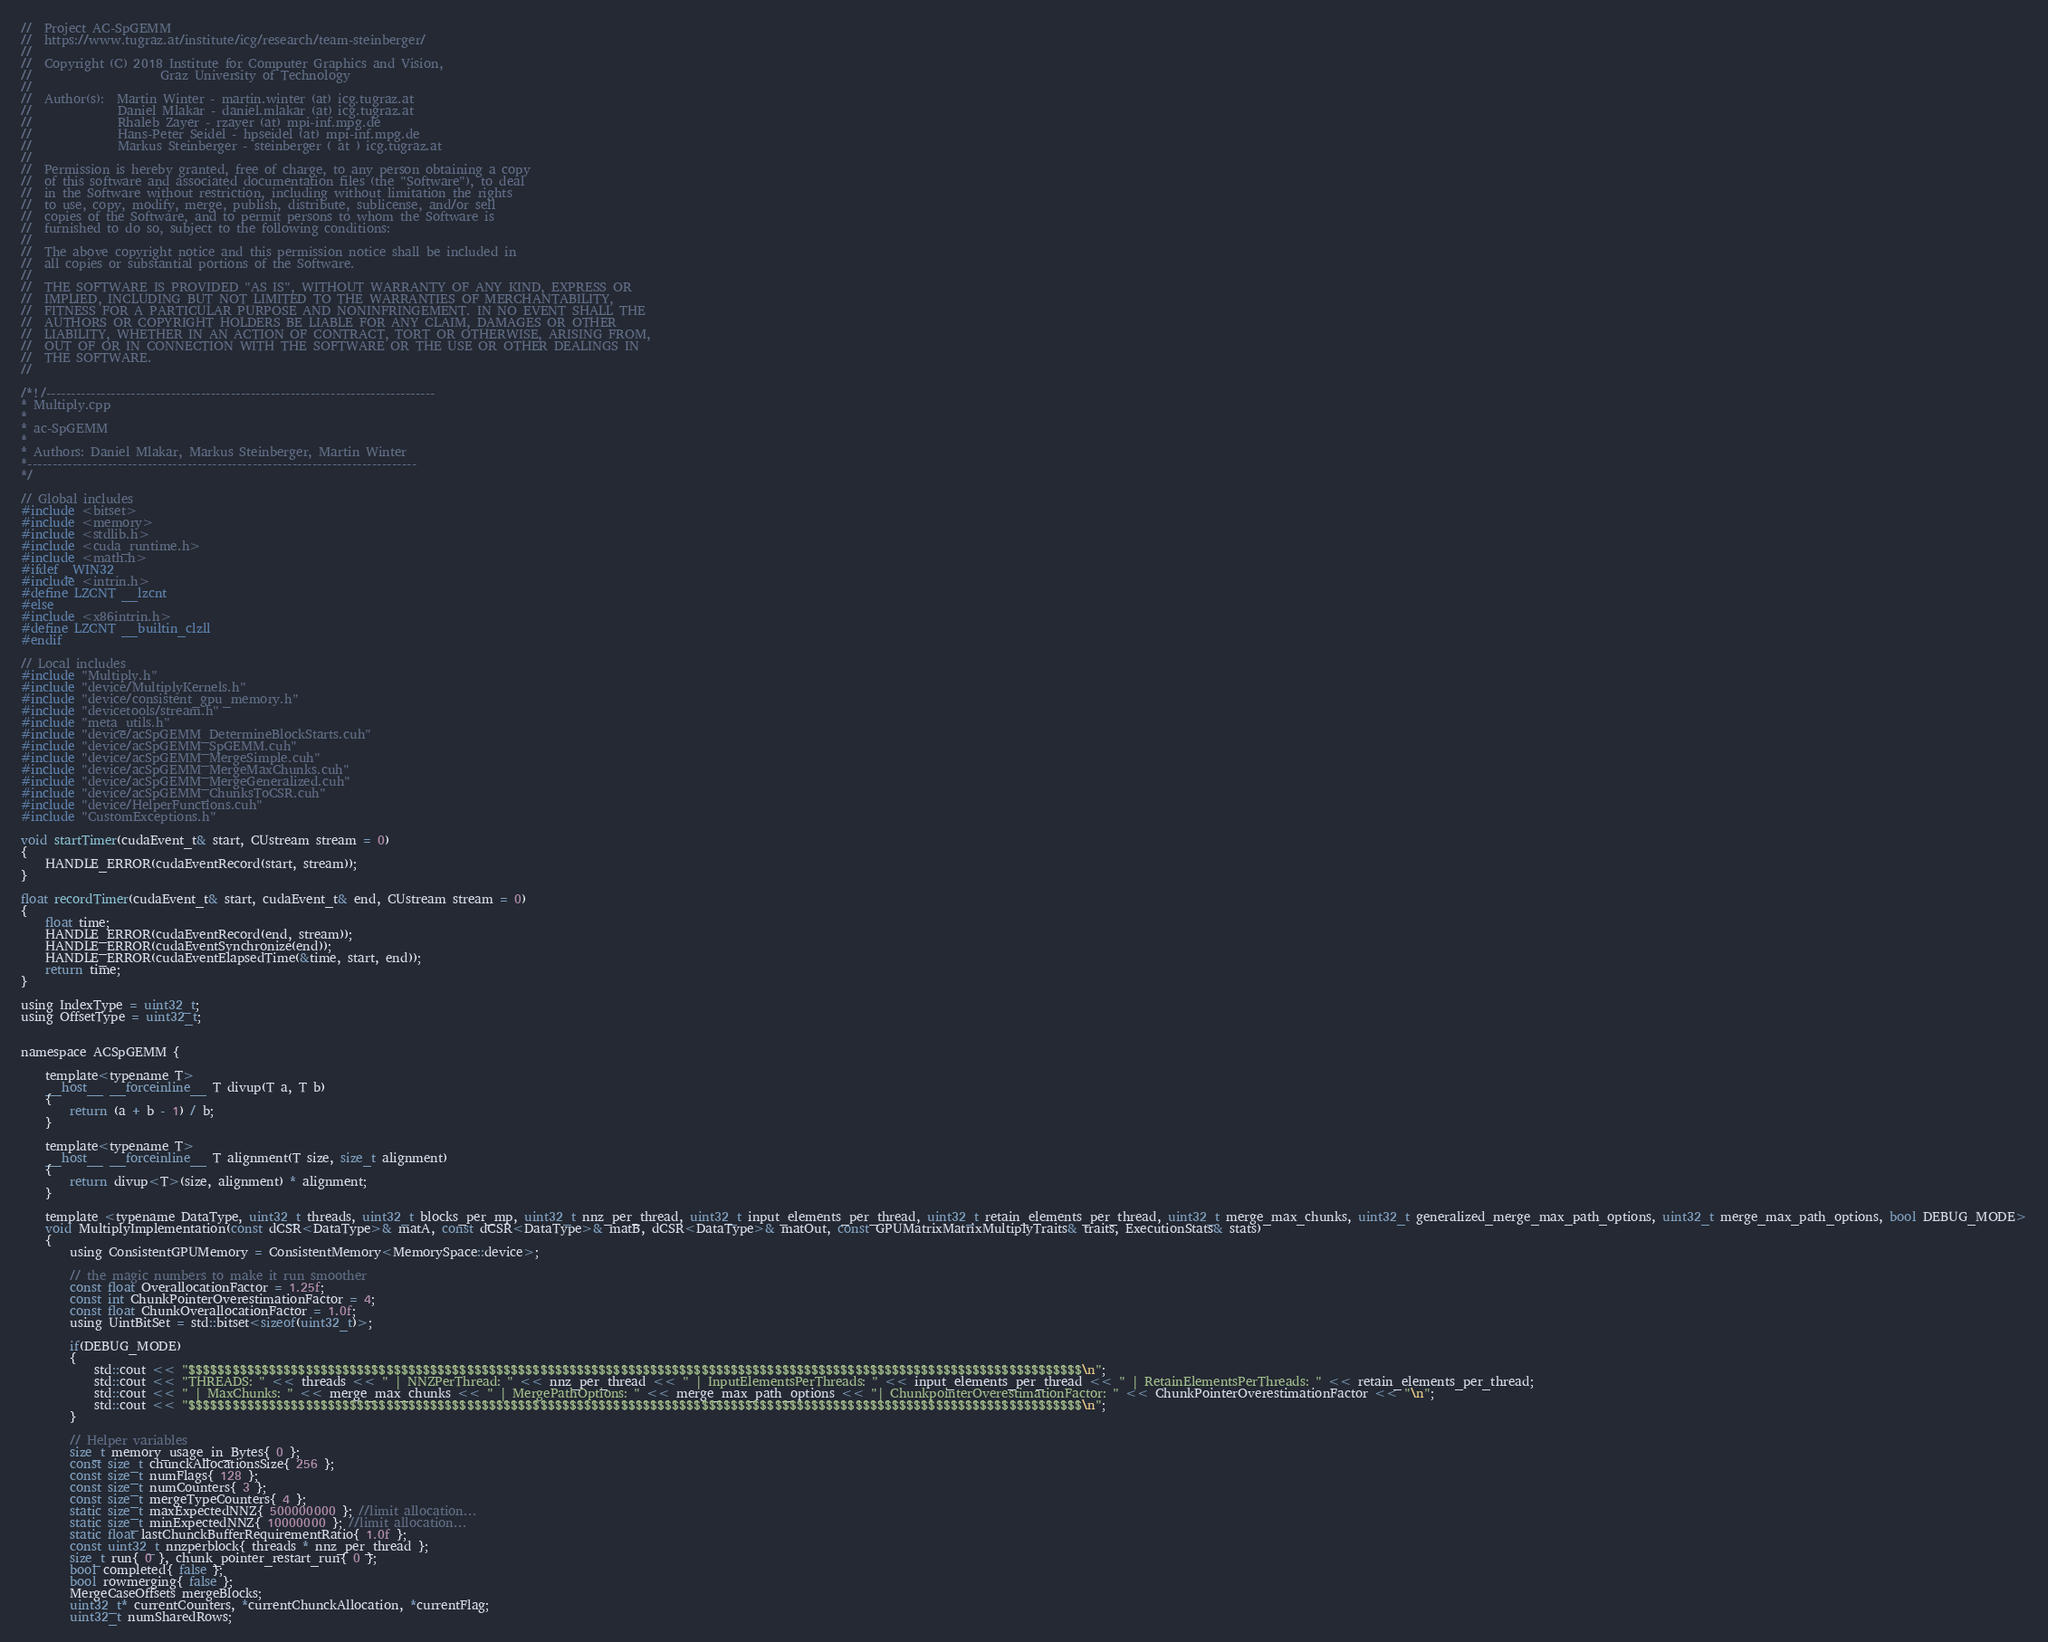<code> <loc_0><loc_0><loc_500><loc_500><_Cuda_>//  Project AC-SpGEMM
//  https://www.tugraz.at/institute/icg/research/team-steinberger/
//
//  Copyright (C) 2018 Institute for Computer Graphics and Vision,
//                     Graz University of Technology
//
//  Author(s):  Martin Winter - martin.winter (at) icg.tugraz.at
//              Daniel Mlakar - daniel.mlakar (at) icg.tugraz.at
//              Rhaleb Zayer - rzayer (at) mpi-inf.mpg.de
//              Hans-Peter Seidel - hpseidel (at) mpi-inf.mpg.de
//              Markus Steinberger - steinberger ( at ) icg.tugraz.at
//
//  Permission is hereby granted, free of charge, to any person obtaining a copy
//  of this software and associated documentation files (the "Software"), to deal
//  in the Software without restriction, including without limitation the rights
//  to use, copy, modify, merge, publish, distribute, sublicense, and/or sell
//  copies of the Software, and to permit persons to whom the Software is
//  furnished to do so, subject to the following conditions:
//
//  The above copyright notice and this permission notice shall be included in
//  all copies or substantial portions of the Software.
//
//  THE SOFTWARE IS PROVIDED "AS IS", WITHOUT WARRANTY OF ANY KIND, EXPRESS OR
//  IMPLIED, INCLUDING BUT NOT LIMITED TO THE WARRANTIES OF MERCHANTABILITY,
//  FITNESS FOR A PARTICULAR PURPOSE AND NONINFRINGEMENT. IN NO EVENT SHALL THE
//  AUTHORS OR COPYRIGHT HOLDERS BE LIABLE FOR ANY CLAIM, DAMAGES OR OTHER
//  LIABILITY, WHETHER IN AN ACTION OF CONTRACT, TORT OR OTHERWISE, ARISING FROM,
//  OUT OF OR IN CONNECTION WITH THE SOFTWARE OR THE USE OR OTHER DEALINGS IN
//  THE SOFTWARE.
//

/*!/------------------------------------------------------------------------------
* Multiply.cpp
*
* ac-SpGEMM
*
* Authors: Daniel Mlakar, Markus Steinberger, Martin Winter
*------------------------------------------------------------------------------
*/

// Global includes
#include <bitset>
#include <memory>
#include <stdlib.h>
#include <cuda_runtime.h>
#include <math.h>
#ifdef _WIN32
#include <intrin.h>
#define LZCNT __lzcnt
#else
#include <x86intrin.h>
#define LZCNT __builtin_clzll
#endif

// Local includes
#include "Multiply.h"
#include "device/MultiplyKernels.h"
#include "device/consistent_gpu_memory.h"
#include "devicetools/stream.h"
#include "meta_utils.h"
#include "device/acSpGEMM_DetermineBlockStarts.cuh"
#include "device/acSpGEMM_SpGEMM.cuh"
#include "device/acSpGEMM_MergeSimple.cuh"
#include "device/acSpGEMM_MergeMaxChunks.cuh"
#include "device/acSpGEMM_MergeGeneralized.cuh"
#include "device/acSpGEMM_ChunksToCSR.cuh"
#include "device/HelperFunctions.cuh"
#include "CustomExceptions.h"

void startTimer(cudaEvent_t& start, CUstream stream = 0)
{
	HANDLE_ERROR(cudaEventRecord(start, stream));
}

float recordTimer(cudaEvent_t& start, cudaEvent_t& end, CUstream stream = 0)
{
	float time;
	HANDLE_ERROR(cudaEventRecord(end, stream));
	HANDLE_ERROR(cudaEventSynchronize(end));
	HANDLE_ERROR(cudaEventElapsedTime(&time, start, end));
	return time;
}

using IndexType = uint32_t;
using OffsetType = uint32_t;


namespace ACSpGEMM {

	template<typename T>
	__host__ __forceinline__ T divup(T a, T b)
	{
		return (a + b - 1) / b;
	}

	template<typename T>
	__host__ __forceinline__ T alignment(T size, size_t alignment)
	{
		return divup<T>(size, alignment) * alignment;
	}

	template <typename DataType, uint32_t threads, uint32_t blocks_per_mp, uint32_t nnz_per_thread, uint32_t input_elements_per_thread, uint32_t retain_elements_per_thread, uint32_t merge_max_chunks, uint32_t generalized_merge_max_path_options, uint32_t merge_max_path_options, bool DEBUG_MODE>
	void MultiplyImplementation(const dCSR<DataType>& matA, const dCSR<DataType>& matB, dCSR<DataType>& matOut, const GPUMatrixMatrixMultiplyTraits& traits, ExecutionStats& stats)
	{
		using ConsistentGPUMemory = ConsistentMemory<MemorySpace::device>;
		
		// the magic numbers to make it run smoother
		const float OverallocationFactor = 1.25f;
		const int ChunkPointerOverestimationFactor = 4;
		const float ChunkOverallocationFactor = 1.0f;
		using UintBitSet = std::bitset<sizeof(uint32_t)>;

		if(DEBUG_MODE)
		{
			std::cout << "$$$$$$$$$$$$$$$$$$$$$$$$$$$$$$$$$$$$$$$$$$$$$$$$$$$$$$$$$$$$$$$$$$$$$$$$$$$$$$$$$$$$$$$$$$$$$$$$$$$$$$$$$$$$$$$$$$$$$$$$$$\n";
			std::cout << "THREADS: " << threads << " | NNZPerThread: " << nnz_per_thread << " | InputElementsPerThreads: " << input_elements_per_thread << " | RetainElementsPerThreads: " << retain_elements_per_thread;
			std::cout << " | MaxChunks: " << merge_max_chunks << " | MergePathOptions: " << merge_max_path_options << "| ChunkpointerOverestimationFactor: " << ChunkPointerOverestimationFactor << "\n";
			std::cout << "$$$$$$$$$$$$$$$$$$$$$$$$$$$$$$$$$$$$$$$$$$$$$$$$$$$$$$$$$$$$$$$$$$$$$$$$$$$$$$$$$$$$$$$$$$$$$$$$$$$$$$$$$$$$$$$$$$$$$$$$$$\n";
		}

		// Helper variables
		size_t memory_usage_in_Bytes{ 0 };
		const size_t chunckAllocationsSize{ 256 };
		const size_t numFlags{ 128 };
		const size_t numCounters{ 3 };
		const size_t mergeTypeCounters{ 4 };
		static size_t maxExpectedNNZ{ 500000000 }; //limit allocation...
		static size_t minExpectedNNZ{ 10000000 }; //limit allocation...
		static float lastChunckBufferRequirementRatio{ 1.0f };
		const uint32_t nnzperblock{ threads * nnz_per_thread };
		size_t run{ 0 }, chunk_pointer_restart_run{ 0 };
		bool completed{ false };
		bool rowmerging{ false };
		MergeCaseOffsets mergeBlocks;
		uint32_t* currentCounters, *currentChunckAllocation, *currentFlag;
		uint32_t numSharedRows;</code> 